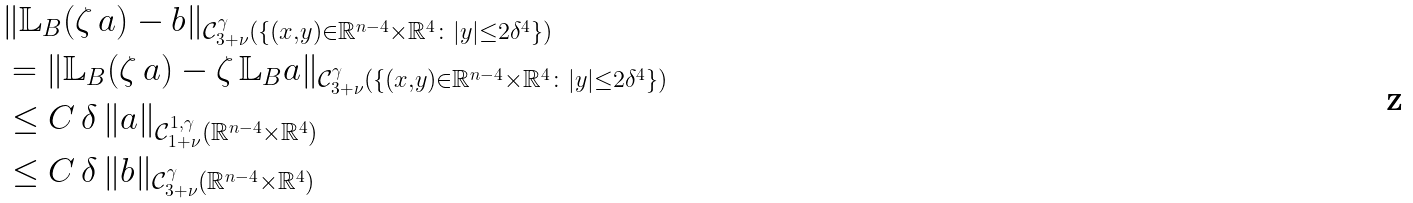<formula> <loc_0><loc_0><loc_500><loc_500>& \| \mathbb { L } _ { B } ( \zeta \, a ) - b \| _ { \mathcal { C } _ { 3 + \nu } ^ { \gamma } ( \{ ( x , y ) \in \mathbb { R } ^ { n - 4 } \times \mathbb { R } ^ { 4 } \colon | y | \leq 2 \delta ^ { 4 } \} ) } \\ & = \| \mathbb { L } _ { B } ( \zeta \, a ) - \zeta \, \mathbb { L } _ { B } a \| _ { \mathcal { C } _ { 3 + \nu } ^ { \gamma } ( \{ ( x , y ) \in \mathbb { R } ^ { n - 4 } \times \mathbb { R } ^ { 4 } \colon | y | \leq 2 \delta ^ { 4 } \} ) } \\ & \leq C \, \delta \, \| a \| _ { \mathcal { C } _ { 1 + \nu } ^ { 1 , \gamma } ( \mathbb { R } ^ { n - 4 } \times \mathbb { R } ^ { 4 } ) } \\ & \leq C \, \delta \, \| b \| _ { \mathcal { C } _ { 3 + \nu } ^ { \gamma } ( \mathbb { R } ^ { n - 4 } \times \mathbb { R } ^ { 4 } ) }</formula> 